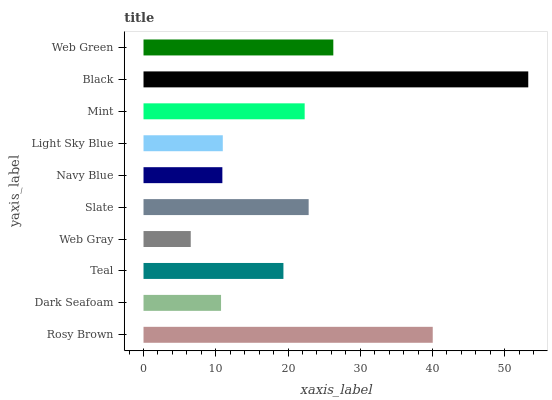Is Web Gray the minimum?
Answer yes or no. Yes. Is Black the maximum?
Answer yes or no. Yes. Is Dark Seafoam the minimum?
Answer yes or no. No. Is Dark Seafoam the maximum?
Answer yes or no. No. Is Rosy Brown greater than Dark Seafoam?
Answer yes or no. Yes. Is Dark Seafoam less than Rosy Brown?
Answer yes or no. Yes. Is Dark Seafoam greater than Rosy Brown?
Answer yes or no. No. Is Rosy Brown less than Dark Seafoam?
Answer yes or no. No. Is Mint the high median?
Answer yes or no. Yes. Is Teal the low median?
Answer yes or no. Yes. Is Rosy Brown the high median?
Answer yes or no. No. Is Slate the low median?
Answer yes or no. No. 